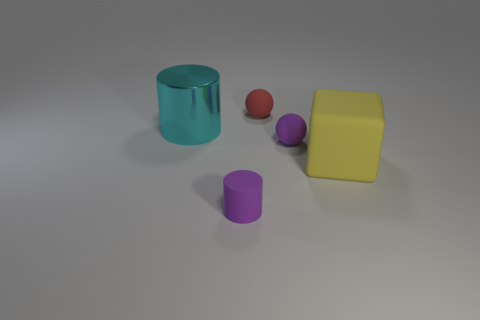Add 3 rubber spheres. How many objects exist? 8 Subtract all cylinders. How many objects are left? 3 Subtract 1 red spheres. How many objects are left? 4 Subtract all balls. Subtract all big brown balls. How many objects are left? 3 Add 5 yellow rubber things. How many yellow rubber things are left? 6 Add 2 small blue cubes. How many small blue cubes exist? 2 